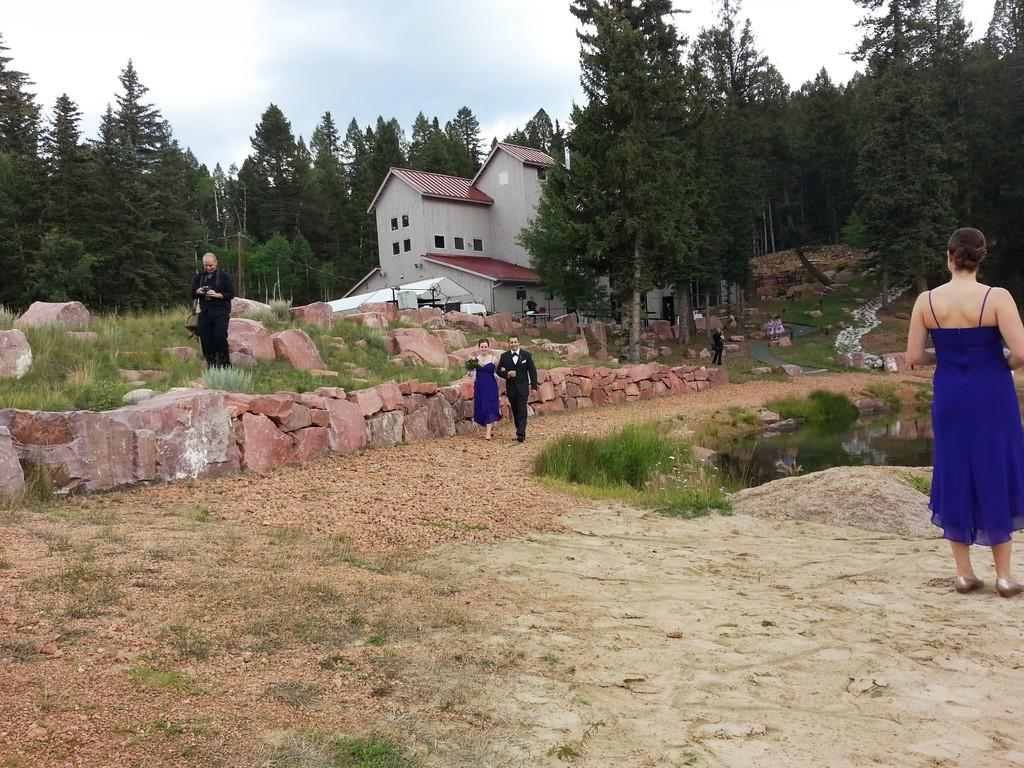What type of structures can be seen in the image? There are buildings in the image. Can you describe the person in the image? There is a person standing on the ground in the image. What type of natural elements are present in the image? Stones, rocks, grass, and trees are visible in the image. Is there a designated path for walking in the image? Yes, there is a walking path in the image. What type of shelter is present in the image? There is a shed in the image. What can be seen in the sky in the image? The sky is visible in the image, and clouds are present. What type of reaction does the authority have towards the turkey in the image? There is no turkey present in the image, so it is not possible to determine any reaction or authority towards it. 